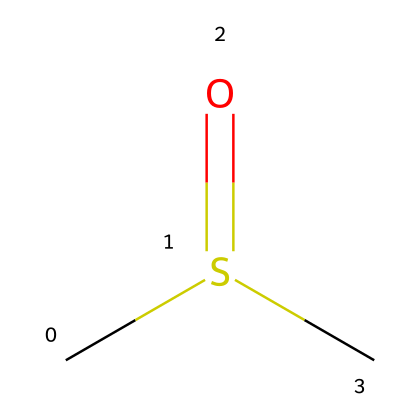What is the molecular formula of dimethyl sulfoxide? The SMILES representation indicates there are 2 carbon atoms (C), 6 hydrogen atoms (H), 1 sulfur atom (S), and 1 oxygen atom (O), leading to the molecular formula C2H6OS.
Answer: C2H6OS How many carbon atoms are present in this compound? By analyzing the SMILES representation, "CS(=O)C," we see there are two instances of the carbon symbol (C), indicating two carbon atoms.
Answer: 2 What type of bond connects the sulfur and oxygen in this molecule? The SMILES notation shows the bond is represented as (=O), indicating a double bond between sulfur (S) and oxygen (O).
Answer: double bond Which functional group is present in dimethyl sulfoxide? The presence of the sulfur atom bonded to oxygen and two methyl (CH3) groups indicates that this compound contains a sulfoxide functional group.
Answer: sulfoxide What is the total number of hydrogen atoms in dimethyl sulfoxide? The chemical structure indicates there are six hydrogen atoms attached to the two carbon atoms, as each methyl group contributes three hydrogen atoms (CH3).
Answer: 6 How does the presence of sulfur affect the polarity of DMSO? Sulfur has different electronegativity compared to carbon and hydrogen, leading to a polar bond with oxygen, making DMSO a polar aprotic solvent.
Answer: increases polarity Is dimethyl sulfoxide considered a solvent? Due to its ability to dissolve a wide range of polar and non-polar substances, dimethyl sulfoxide is classified as a solvent in chemistry.
Answer: yes 